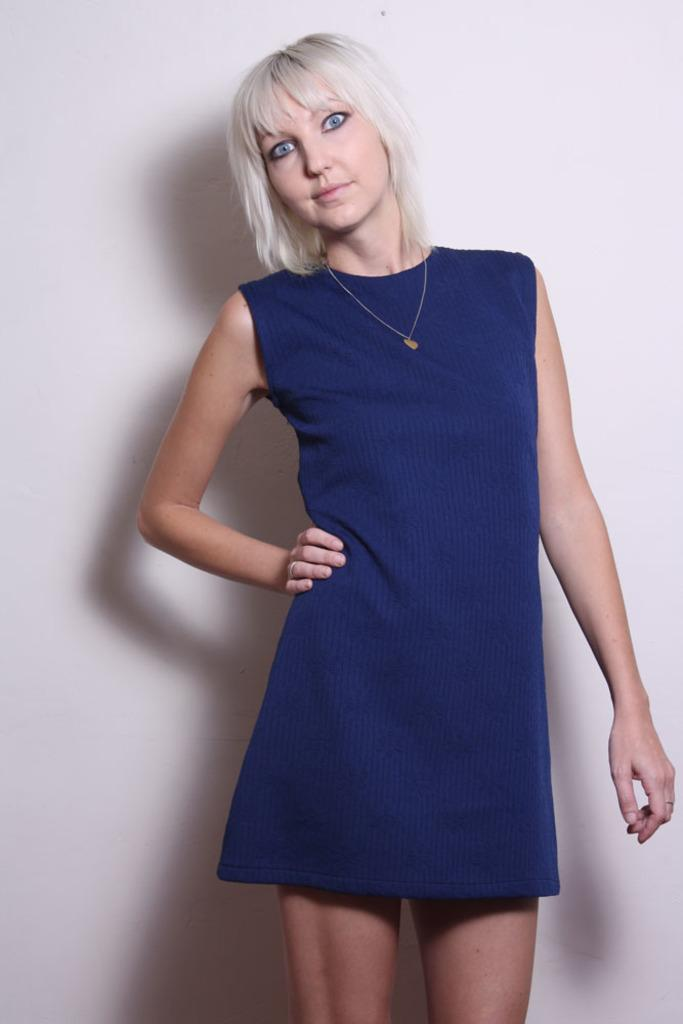What is the main subject of the image? There is a woman in the image. Can you describe the woman's appearance? The woman is wearing a blue dress, has white hair, and blue eyes. Is there anything else notable about the image? Yes, there is a shadow of a woman on the wall in the background of the image. Can you tell me how many bikes are in the image? There are no bikes present in the image. Is there any quicksand visible in the image? There is no quicksand present in the image. 